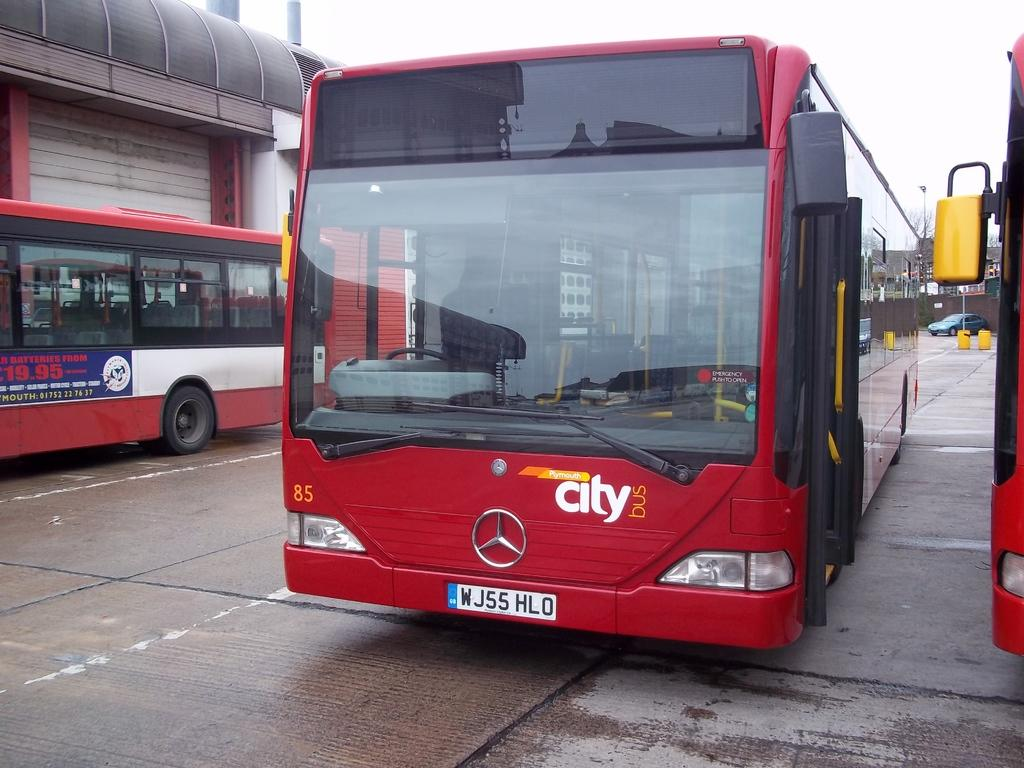<image>
Provide a brief description of the given image. City bus is parked by two other buses in a parking lot 